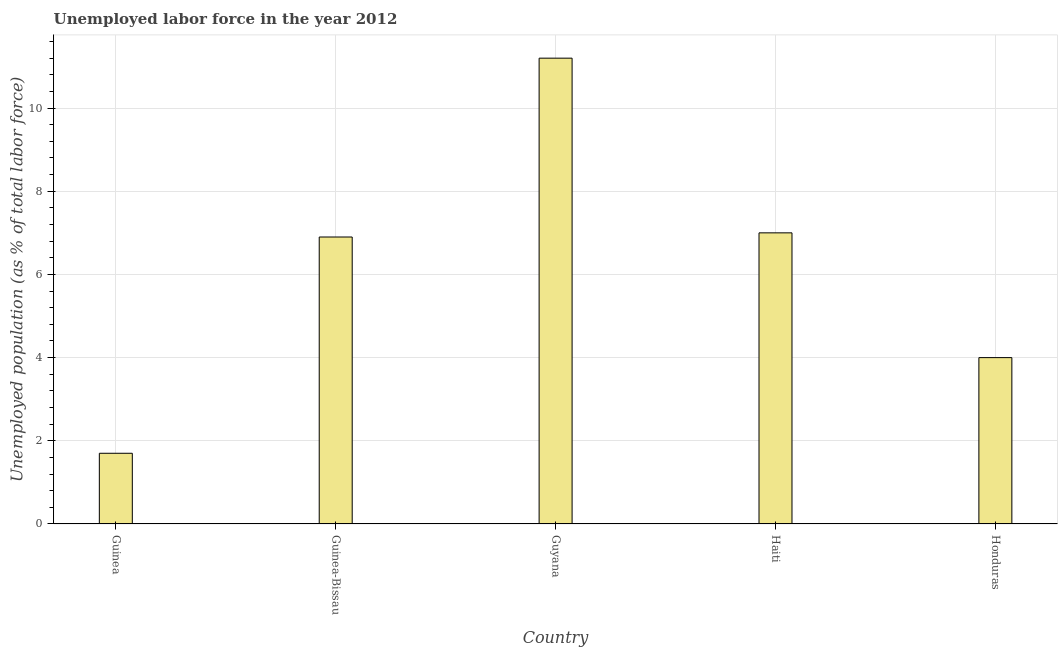Does the graph contain grids?
Make the answer very short. Yes. What is the title of the graph?
Offer a terse response. Unemployed labor force in the year 2012. What is the label or title of the X-axis?
Provide a short and direct response. Country. What is the label or title of the Y-axis?
Keep it short and to the point. Unemployed population (as % of total labor force). What is the total unemployed population in Guyana?
Your answer should be compact. 11.2. Across all countries, what is the maximum total unemployed population?
Your response must be concise. 11.2. Across all countries, what is the minimum total unemployed population?
Give a very brief answer. 1.7. In which country was the total unemployed population maximum?
Ensure brevity in your answer.  Guyana. In which country was the total unemployed population minimum?
Keep it short and to the point. Guinea. What is the sum of the total unemployed population?
Your answer should be very brief. 30.8. What is the difference between the total unemployed population in Guinea-Bissau and Haiti?
Make the answer very short. -0.1. What is the average total unemployed population per country?
Keep it short and to the point. 6.16. What is the median total unemployed population?
Keep it short and to the point. 6.9. Is the sum of the total unemployed population in Haiti and Honduras greater than the maximum total unemployed population across all countries?
Your answer should be compact. No. In how many countries, is the total unemployed population greater than the average total unemployed population taken over all countries?
Your answer should be very brief. 3. How many countries are there in the graph?
Your response must be concise. 5. Are the values on the major ticks of Y-axis written in scientific E-notation?
Keep it short and to the point. No. What is the Unemployed population (as % of total labor force) of Guinea?
Provide a short and direct response. 1.7. What is the Unemployed population (as % of total labor force) in Guinea-Bissau?
Make the answer very short. 6.9. What is the Unemployed population (as % of total labor force) in Guyana?
Provide a succinct answer. 11.2. What is the Unemployed population (as % of total labor force) of Haiti?
Your answer should be very brief. 7. What is the difference between the Unemployed population (as % of total labor force) in Guinea and Guinea-Bissau?
Provide a succinct answer. -5.2. What is the difference between the Unemployed population (as % of total labor force) in Guinea and Guyana?
Offer a very short reply. -9.5. What is the difference between the Unemployed population (as % of total labor force) in Guinea and Haiti?
Offer a very short reply. -5.3. What is the difference between the Unemployed population (as % of total labor force) in Guinea and Honduras?
Give a very brief answer. -2.3. What is the ratio of the Unemployed population (as % of total labor force) in Guinea to that in Guinea-Bissau?
Provide a short and direct response. 0.25. What is the ratio of the Unemployed population (as % of total labor force) in Guinea to that in Guyana?
Provide a succinct answer. 0.15. What is the ratio of the Unemployed population (as % of total labor force) in Guinea to that in Haiti?
Your answer should be very brief. 0.24. What is the ratio of the Unemployed population (as % of total labor force) in Guinea to that in Honduras?
Offer a terse response. 0.42. What is the ratio of the Unemployed population (as % of total labor force) in Guinea-Bissau to that in Guyana?
Offer a terse response. 0.62. What is the ratio of the Unemployed population (as % of total labor force) in Guinea-Bissau to that in Haiti?
Keep it short and to the point. 0.99. What is the ratio of the Unemployed population (as % of total labor force) in Guinea-Bissau to that in Honduras?
Ensure brevity in your answer.  1.73. What is the ratio of the Unemployed population (as % of total labor force) in Guyana to that in Haiti?
Your answer should be very brief. 1.6. What is the ratio of the Unemployed population (as % of total labor force) in Guyana to that in Honduras?
Offer a terse response. 2.8. What is the ratio of the Unemployed population (as % of total labor force) in Haiti to that in Honduras?
Your answer should be compact. 1.75. 